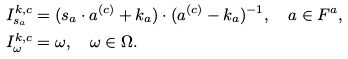<formula> <loc_0><loc_0><loc_500><loc_500>I _ { s _ { a } } ^ { k , c } & = ( s _ { a } \cdot a ^ { ( c ) } + k _ { a } ) \cdot ( a ^ { ( c ) } - k _ { a } ) ^ { - 1 } , \quad a \in F ^ { a } , \\ I _ { \omega } ^ { k , c } & = \omega , \quad \omega \in \Omega .</formula> 